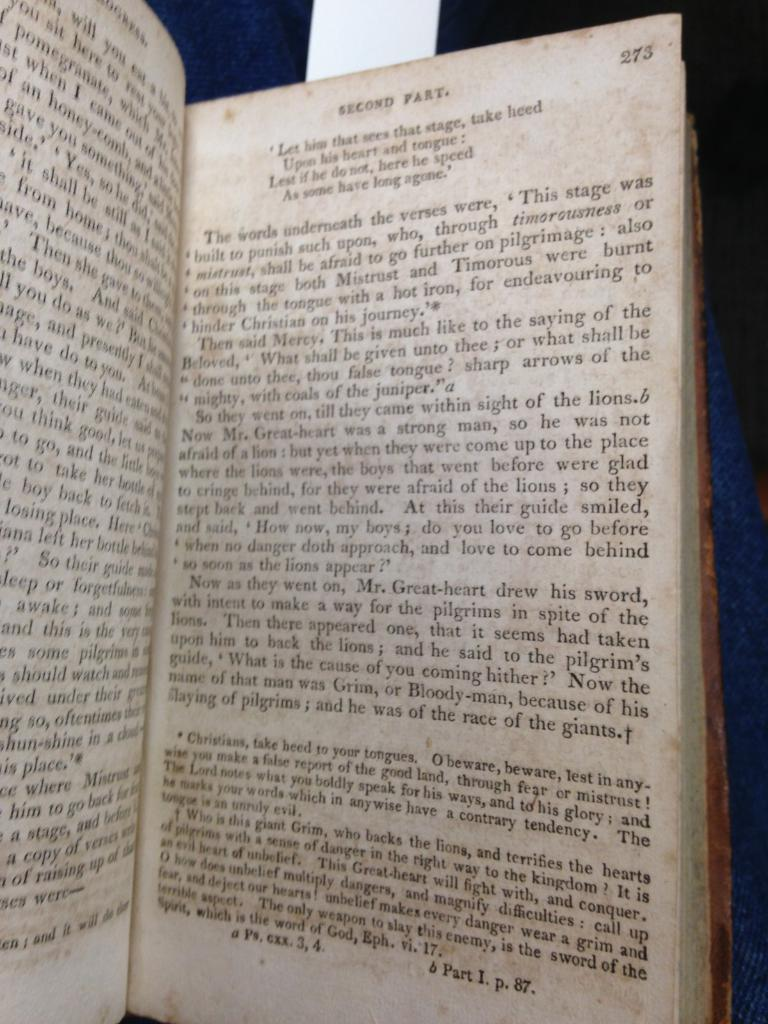<image>
Share a concise interpretation of the image provided. A book is open to page 273 of the second part. 